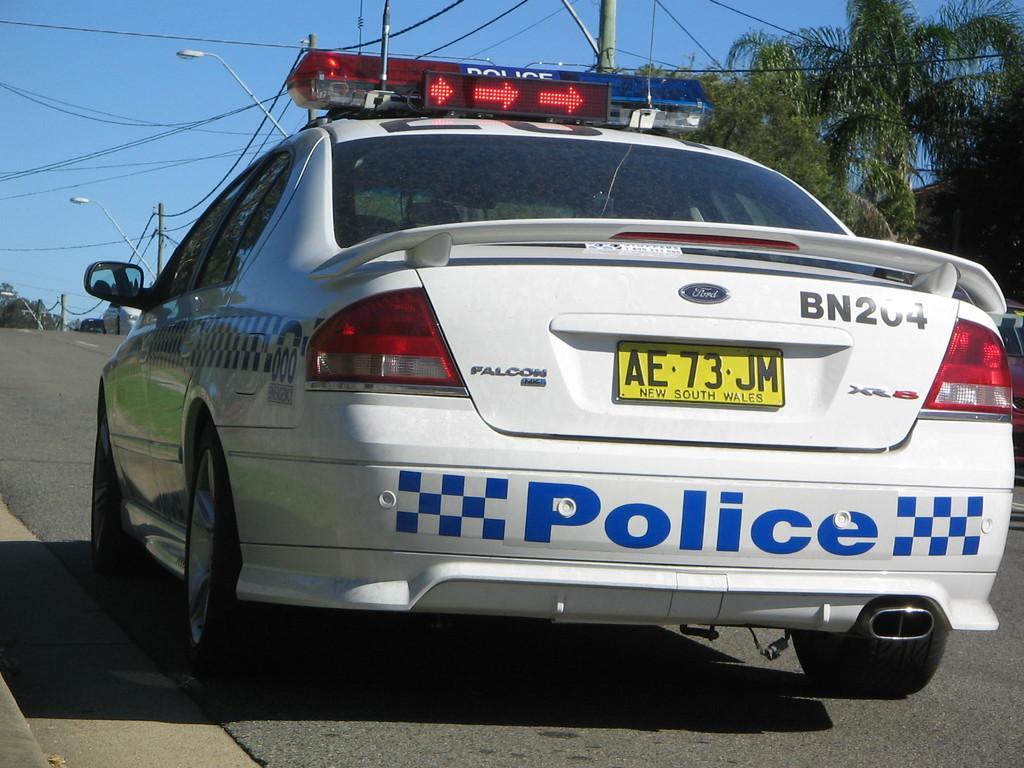In one or two sentences, can you explain what this image depicts? Here I can see a white color car on the road. In the background, I can see few poles and trees. At the top of the image I can see the sky. 